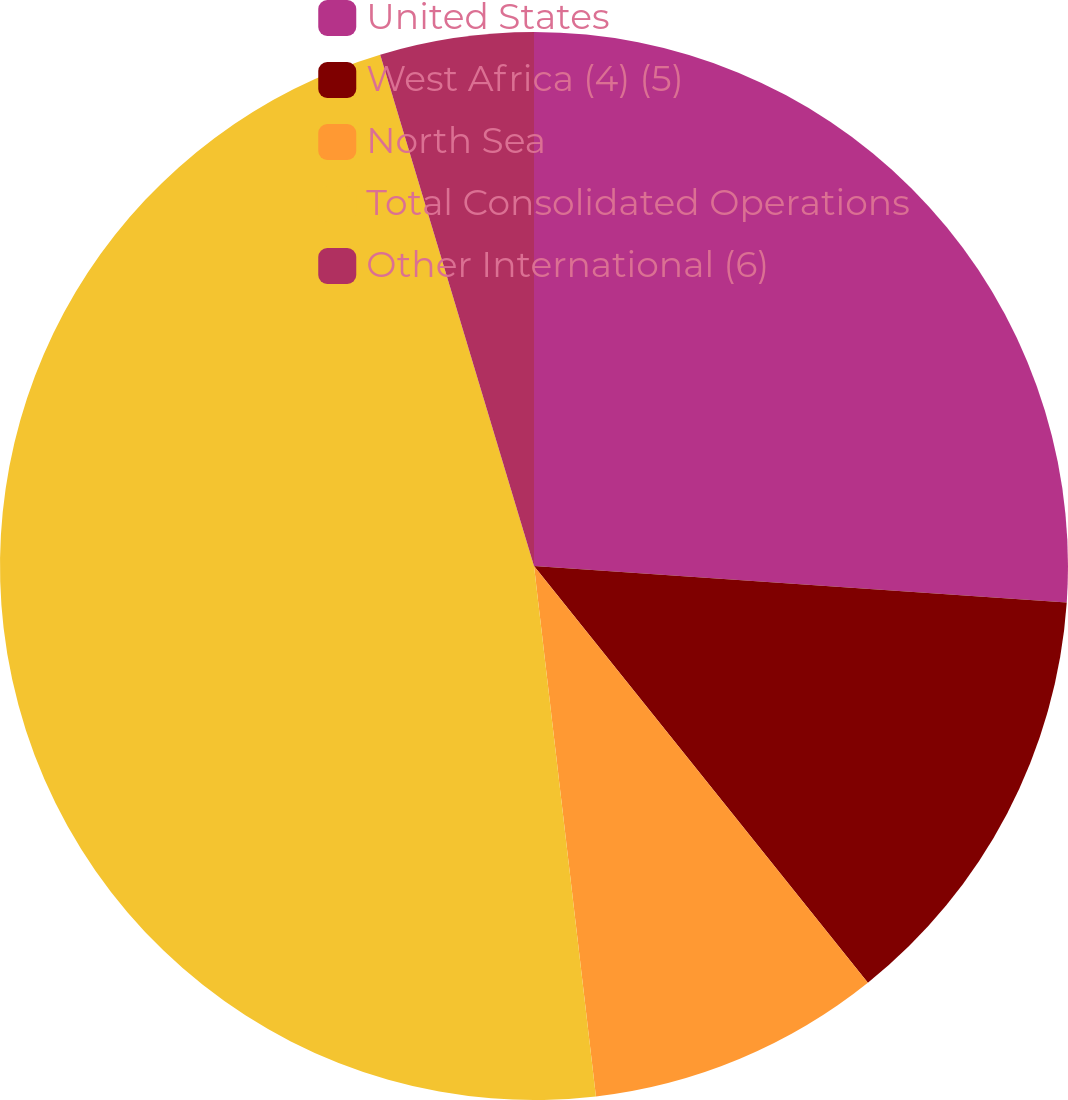Convert chart. <chart><loc_0><loc_0><loc_500><loc_500><pie_chart><fcel>United States<fcel>West Africa (4) (5)<fcel>North Sea<fcel>Total Consolidated Operations<fcel>Other International (6)<nl><fcel>26.09%<fcel>13.16%<fcel>8.9%<fcel>47.2%<fcel>4.65%<nl></chart> 